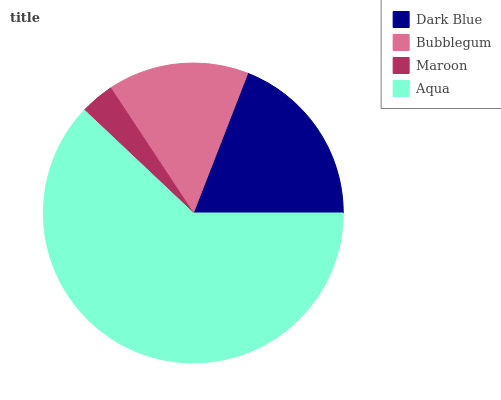Is Maroon the minimum?
Answer yes or no. Yes. Is Aqua the maximum?
Answer yes or no. Yes. Is Bubblegum the minimum?
Answer yes or no. No. Is Bubblegum the maximum?
Answer yes or no. No. Is Dark Blue greater than Bubblegum?
Answer yes or no. Yes. Is Bubblegum less than Dark Blue?
Answer yes or no. Yes. Is Bubblegum greater than Dark Blue?
Answer yes or no. No. Is Dark Blue less than Bubblegum?
Answer yes or no. No. Is Dark Blue the high median?
Answer yes or no. Yes. Is Bubblegum the low median?
Answer yes or no. Yes. Is Maroon the high median?
Answer yes or no. No. Is Aqua the low median?
Answer yes or no. No. 